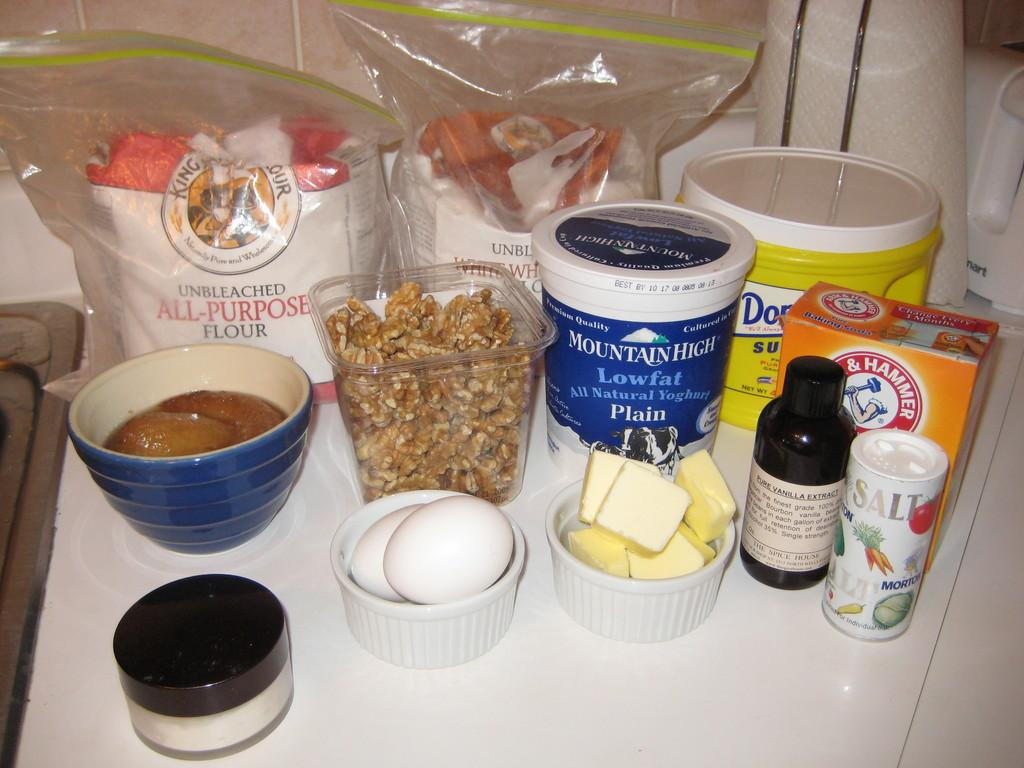Provide a one-sentence caption for the provided image. Baking ingredients are assembled on a countertop, including flour and sugar. 